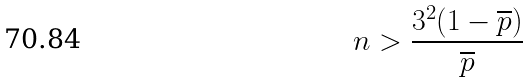Convert formula to latex. <formula><loc_0><loc_0><loc_500><loc_500>n > \frac { 3 ^ { 2 } ( 1 - \overline { p } ) } { \overline { p } }</formula> 